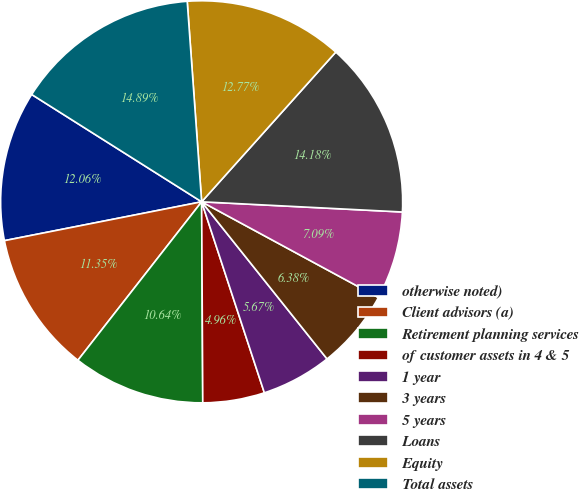<chart> <loc_0><loc_0><loc_500><loc_500><pie_chart><fcel>otherwise noted)<fcel>Client advisors (a)<fcel>Retirement planning services<fcel>of customer assets in 4 & 5<fcel>1 year<fcel>3 years<fcel>5 years<fcel>Loans<fcel>Equity<fcel>Total assets<nl><fcel>12.06%<fcel>11.35%<fcel>10.64%<fcel>4.96%<fcel>5.67%<fcel>6.38%<fcel>7.09%<fcel>14.18%<fcel>12.77%<fcel>14.89%<nl></chart> 